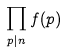Convert formula to latex. <formula><loc_0><loc_0><loc_500><loc_500>\prod _ { p | n } f ( p )</formula> 